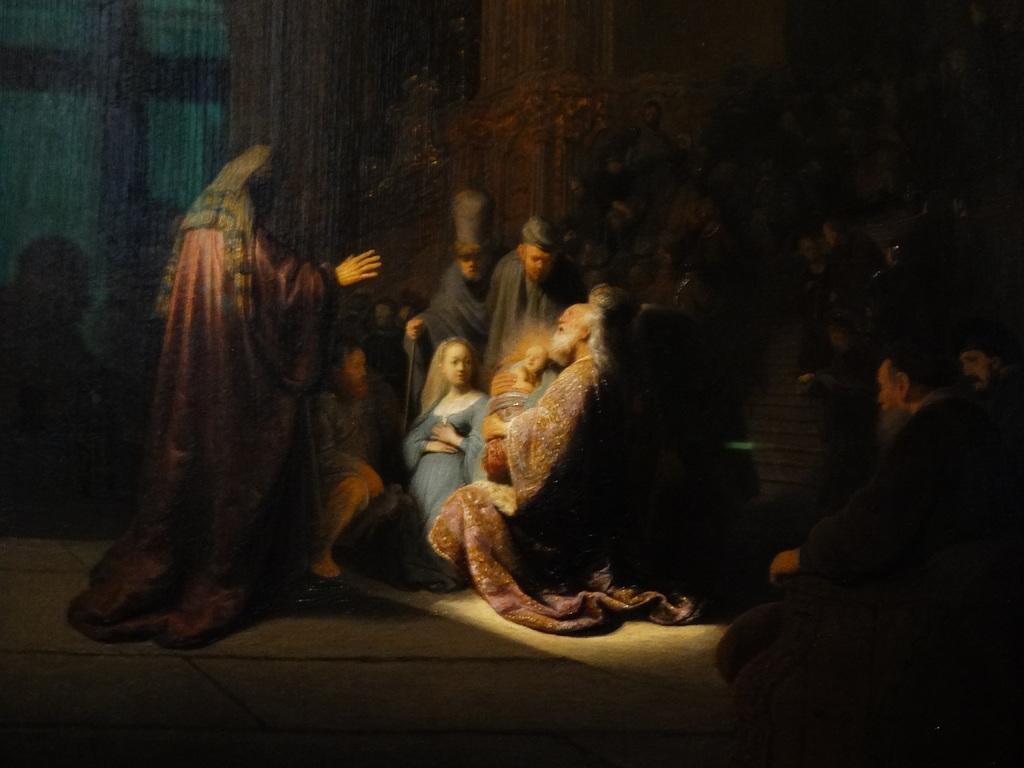Can you describe this image briefly? This picture is consists of a poster, where there are people in the center of the image and there are curtains in the background area of the image. 